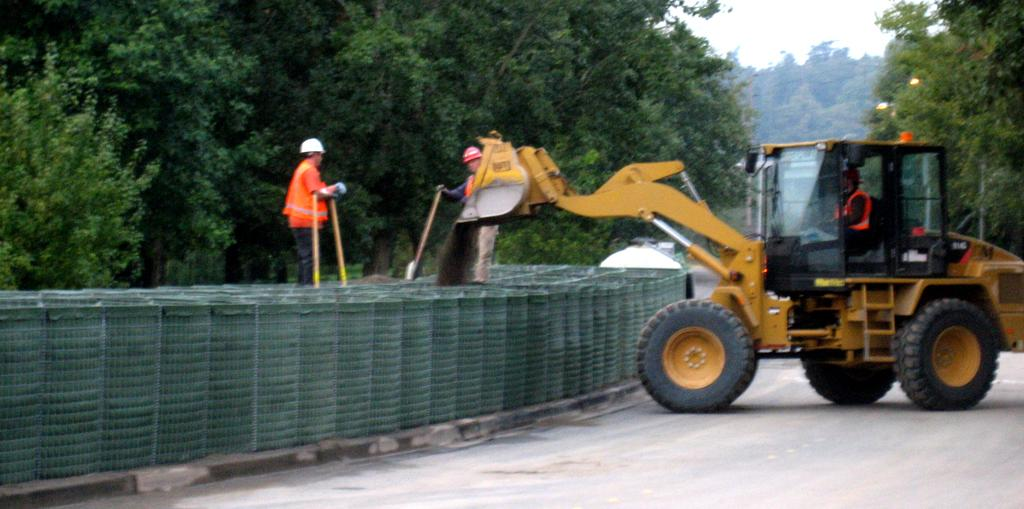What are the two people in the image doing? The two people are standing on a wall. What can be seen behind the people? There is a proclaimer on the road behind the people. What is visible in the background of the image? There are trees visible in the background. What advice is the father giving to the uncle in the image? There is no father or uncle present in the image, so it is not possible to answer that question. 